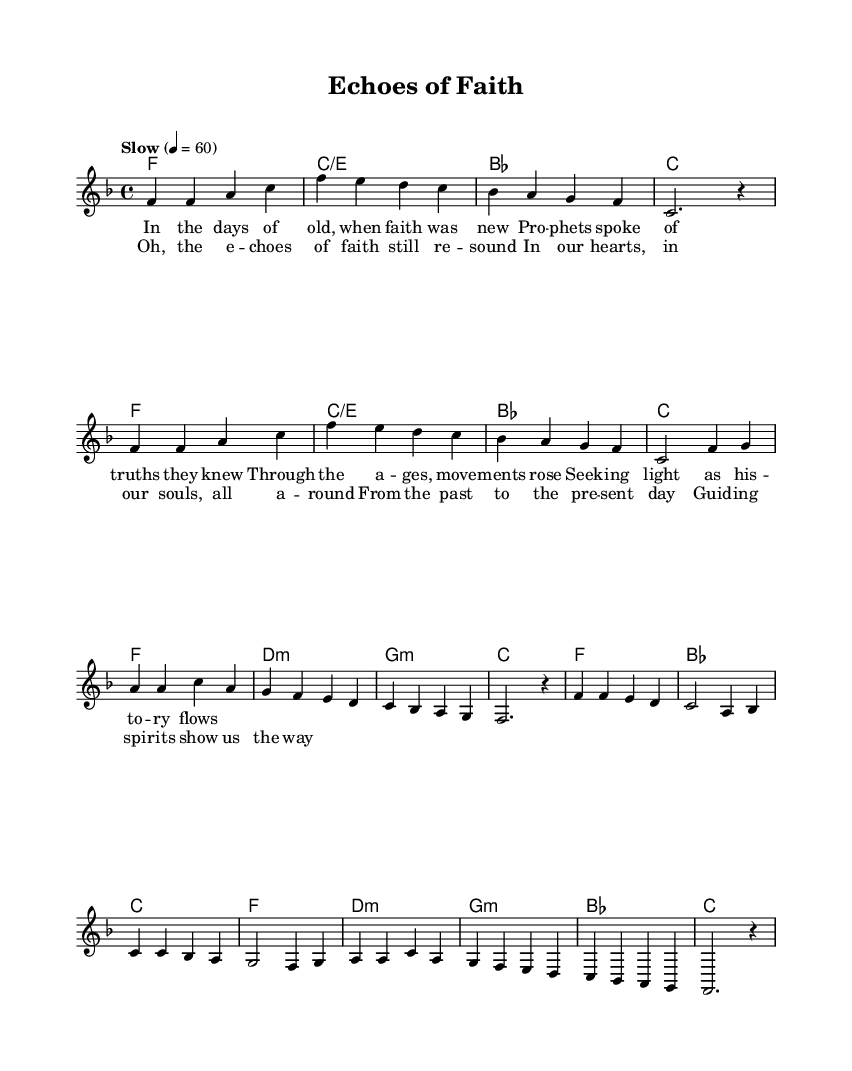What is the key signature of this music? The key signature is F major, which has one flat (B flat).
Answer: F major What is the time signature of this sheet music? The time signature is 4/4, indicating four beats per measure.
Answer: 4/4 What is the tempo marking indicated in the music? The tempo marking indicates "Slow" at 60 beats per minute.
Answer: Slow How many measures are there in the chorus section? The chorus consists of four measures, identifiable by the repeated lyrical structure and notation within the score.
Answer: 4 What chord follows the G minor chord in the verse? After the G minor chord in the verse, the music transitions to a C chord.
Answer: C Which lyrical theme is present in the first verse? The theme of faith and historical movements is prevalent, discussing prophets and truths over ages.
Answer: Faith and historical movements What is the predominant musical style reflected in this piece? The predominant musical style is Rhythm and Blues, characterized by its soulful melodies and emotional lyrics.
Answer: Rhythm and Blues 